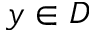<formula> <loc_0><loc_0><loc_500><loc_500>y \in D</formula> 